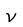<formula> <loc_0><loc_0><loc_500><loc_500>\nu</formula> 